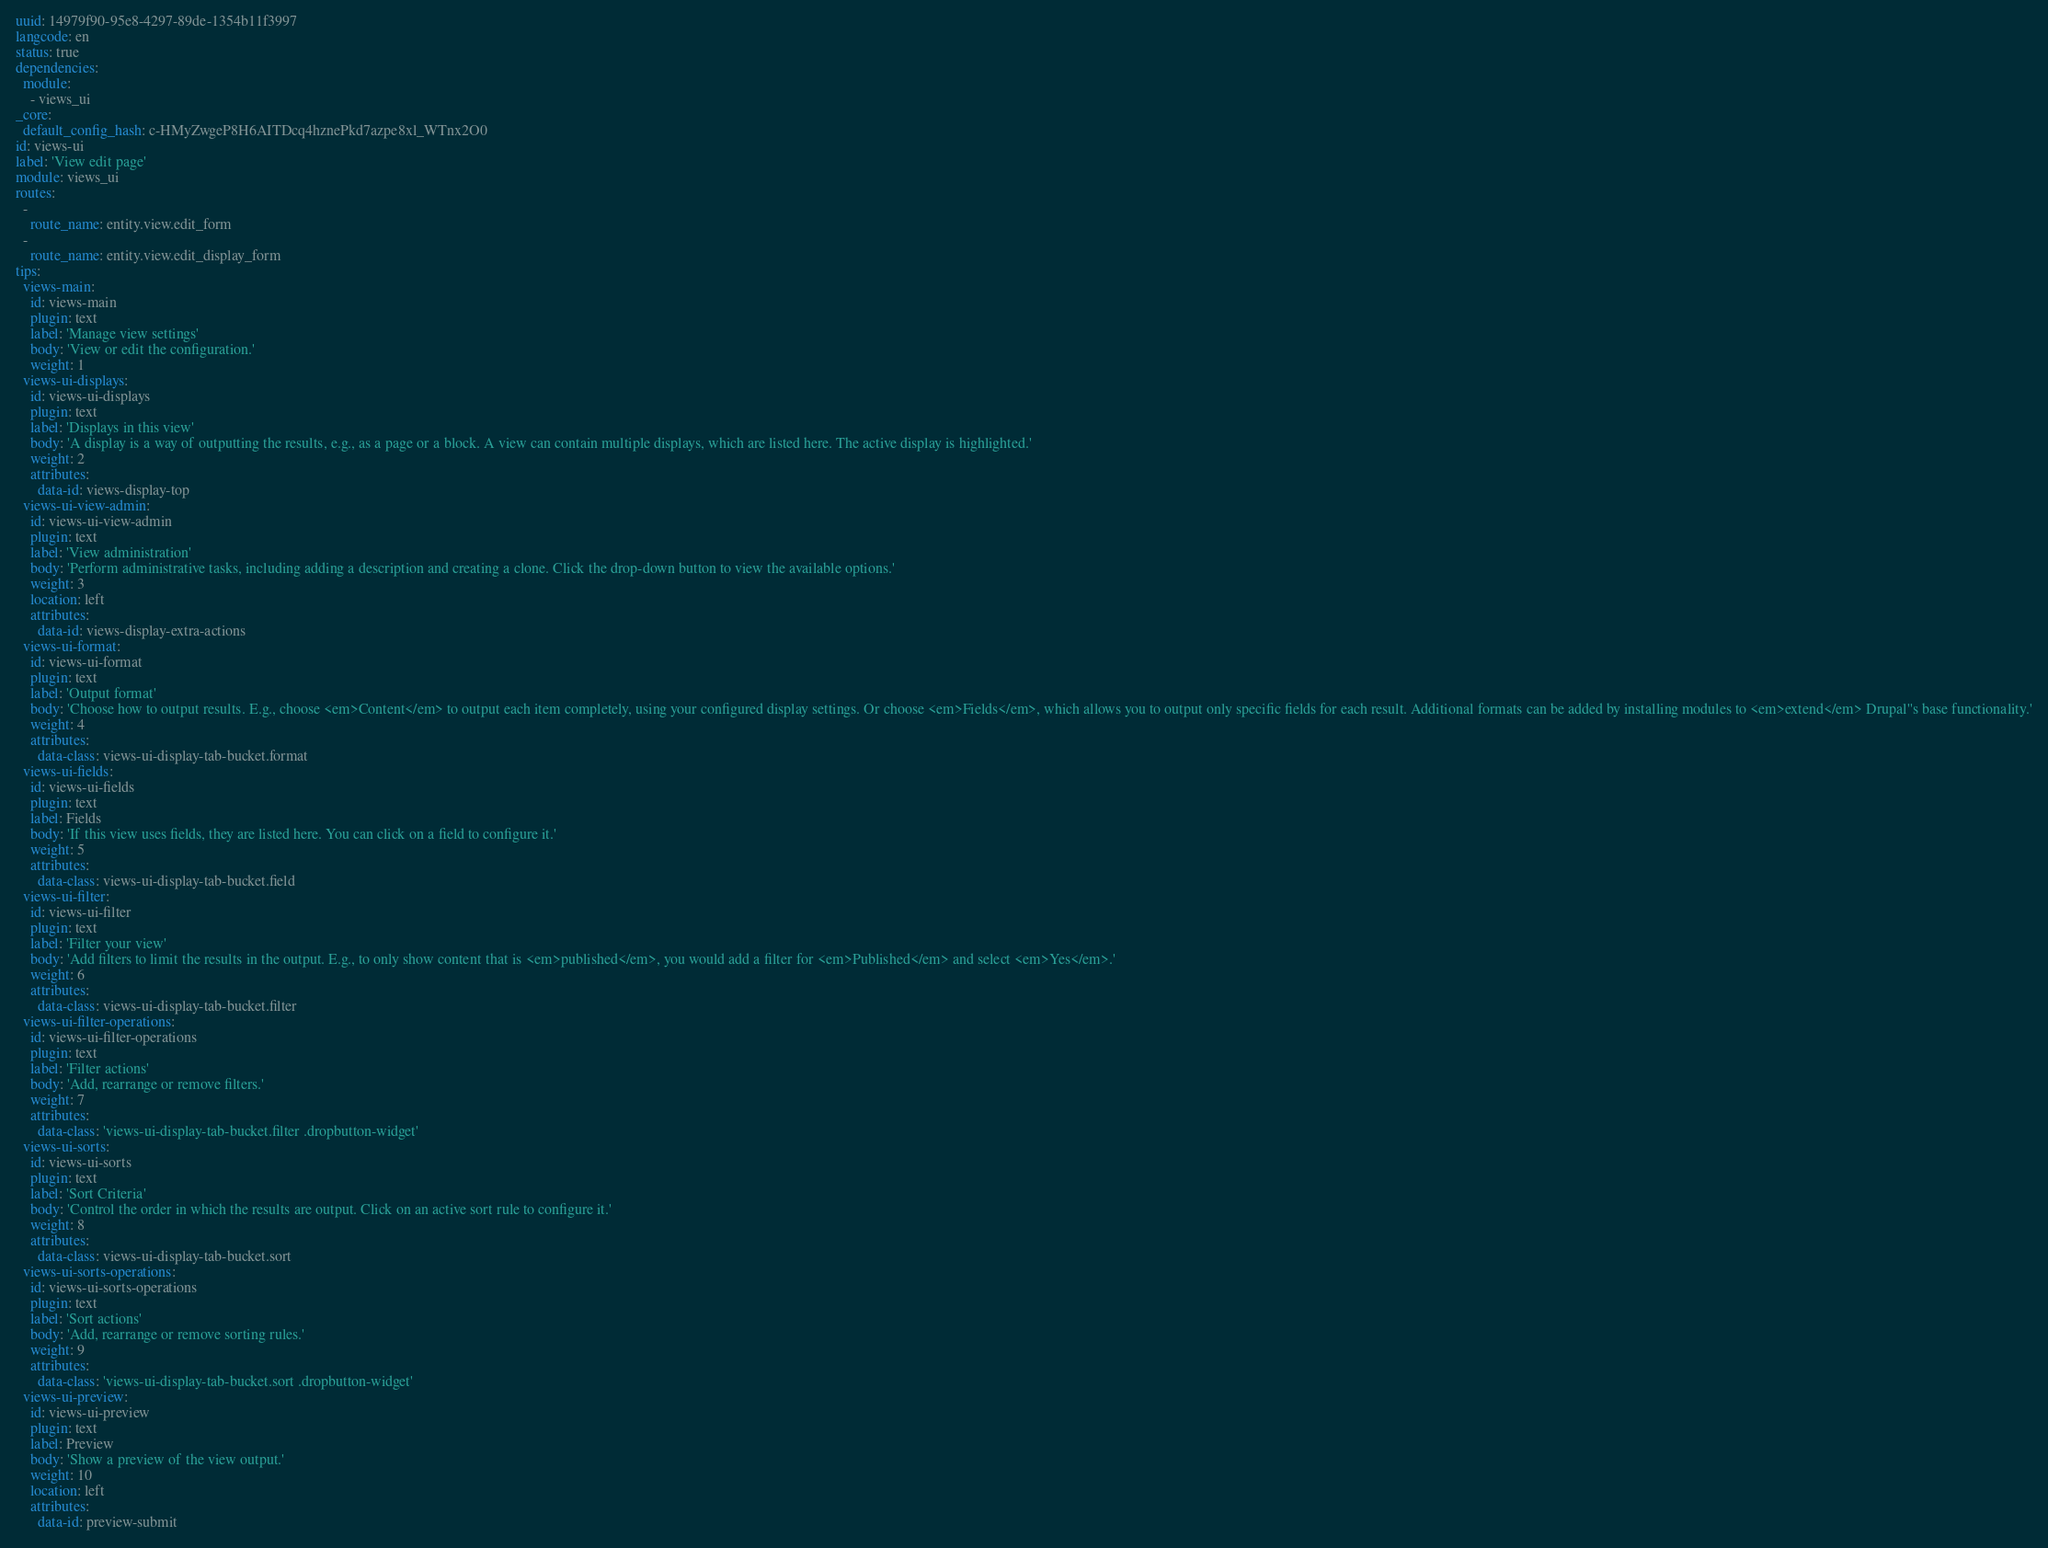Convert code to text. <code><loc_0><loc_0><loc_500><loc_500><_YAML_>uuid: 14979f90-95e8-4297-89de-1354b11f3997
langcode: en
status: true
dependencies:
  module:
    - views_ui
_core:
  default_config_hash: c-HMyZwgeP8H6AITDcq4hznePkd7azpe8xl_WTnx2O0
id: views-ui
label: 'View edit page'
module: views_ui
routes:
  -
    route_name: entity.view.edit_form
  -
    route_name: entity.view.edit_display_form
tips:
  views-main:
    id: views-main
    plugin: text
    label: 'Manage view settings'
    body: 'View or edit the configuration.'
    weight: 1
  views-ui-displays:
    id: views-ui-displays
    plugin: text
    label: 'Displays in this view'
    body: 'A display is a way of outputting the results, e.g., as a page or a block. A view can contain multiple displays, which are listed here. The active display is highlighted.'
    weight: 2
    attributes:
      data-id: views-display-top
  views-ui-view-admin:
    id: views-ui-view-admin
    plugin: text
    label: 'View administration'
    body: 'Perform administrative tasks, including adding a description and creating a clone. Click the drop-down button to view the available options.'
    weight: 3
    location: left
    attributes:
      data-id: views-display-extra-actions
  views-ui-format:
    id: views-ui-format
    plugin: text
    label: 'Output format'
    body: 'Choose how to output results. E.g., choose <em>Content</em> to output each item completely, using your configured display settings. Or choose <em>Fields</em>, which allows you to output only specific fields for each result. Additional formats can be added by installing modules to <em>extend</em> Drupal''s base functionality.'
    weight: 4
    attributes:
      data-class: views-ui-display-tab-bucket.format
  views-ui-fields:
    id: views-ui-fields
    plugin: text
    label: Fields
    body: 'If this view uses fields, they are listed here. You can click on a field to configure it.'
    weight: 5
    attributes:
      data-class: views-ui-display-tab-bucket.field
  views-ui-filter:
    id: views-ui-filter
    plugin: text
    label: 'Filter your view'
    body: 'Add filters to limit the results in the output. E.g., to only show content that is <em>published</em>, you would add a filter for <em>Published</em> and select <em>Yes</em>.'
    weight: 6
    attributes:
      data-class: views-ui-display-tab-bucket.filter
  views-ui-filter-operations:
    id: views-ui-filter-operations
    plugin: text
    label: 'Filter actions'
    body: 'Add, rearrange or remove filters.'
    weight: 7
    attributes:
      data-class: 'views-ui-display-tab-bucket.filter .dropbutton-widget'
  views-ui-sorts:
    id: views-ui-sorts
    plugin: text
    label: 'Sort Criteria'
    body: 'Control the order in which the results are output. Click on an active sort rule to configure it.'
    weight: 8
    attributes:
      data-class: views-ui-display-tab-bucket.sort
  views-ui-sorts-operations:
    id: views-ui-sorts-operations
    plugin: text
    label: 'Sort actions'
    body: 'Add, rearrange or remove sorting rules.'
    weight: 9
    attributes:
      data-class: 'views-ui-display-tab-bucket.sort .dropbutton-widget'
  views-ui-preview:
    id: views-ui-preview
    plugin: text
    label: Preview
    body: 'Show a preview of the view output.'
    weight: 10
    location: left
    attributes:
      data-id: preview-submit
</code> 